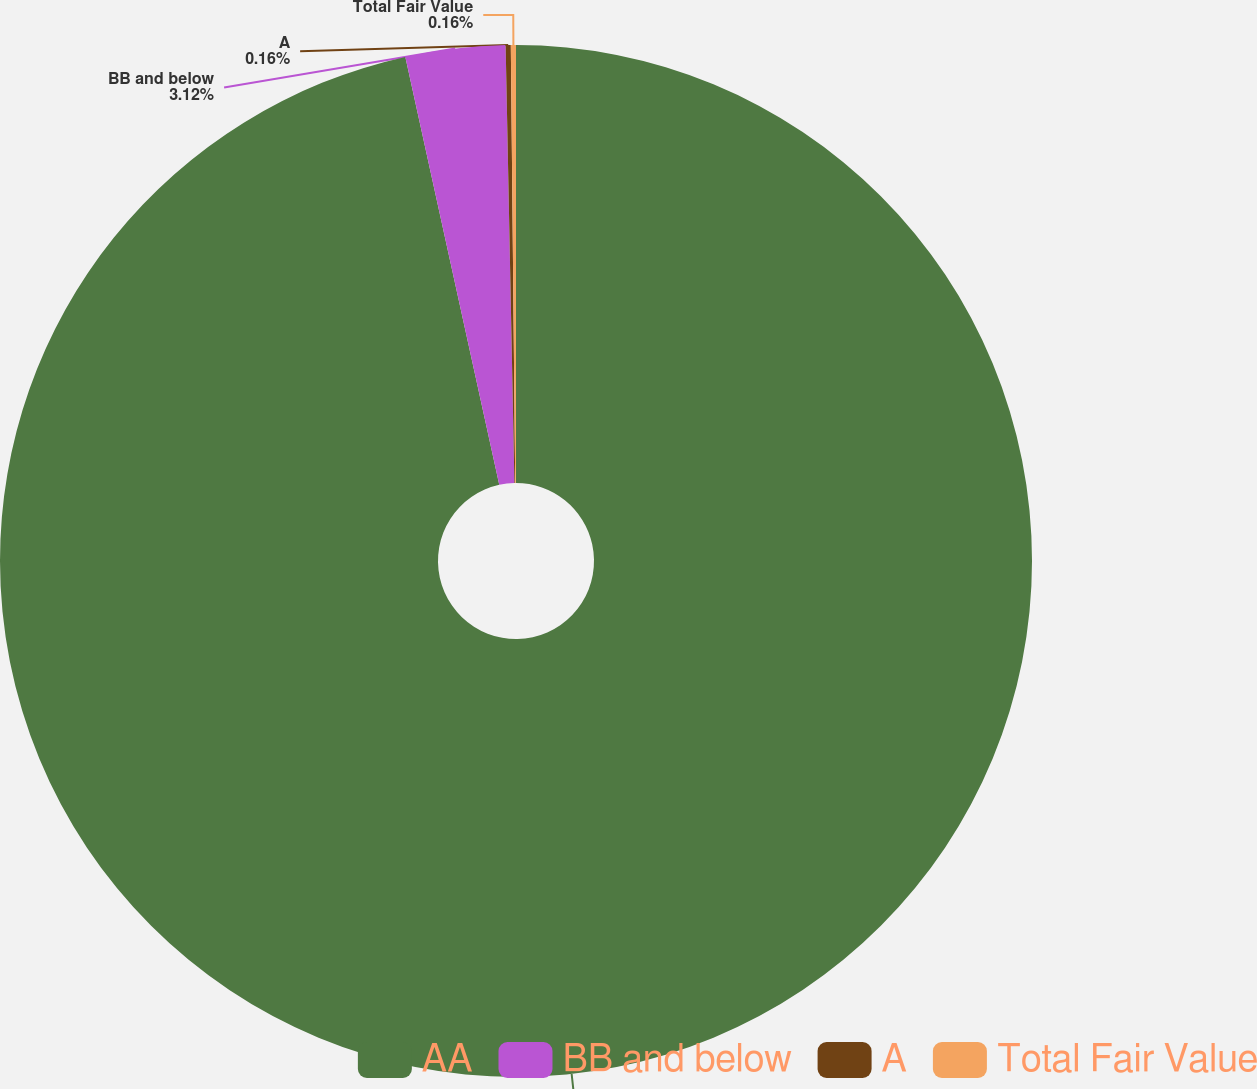Convert chart to OTSL. <chart><loc_0><loc_0><loc_500><loc_500><pie_chart><fcel>AA<fcel>BB and below<fcel>A<fcel>Total Fair Value<nl><fcel>96.56%<fcel>3.12%<fcel>0.16%<fcel>0.16%<nl></chart> 